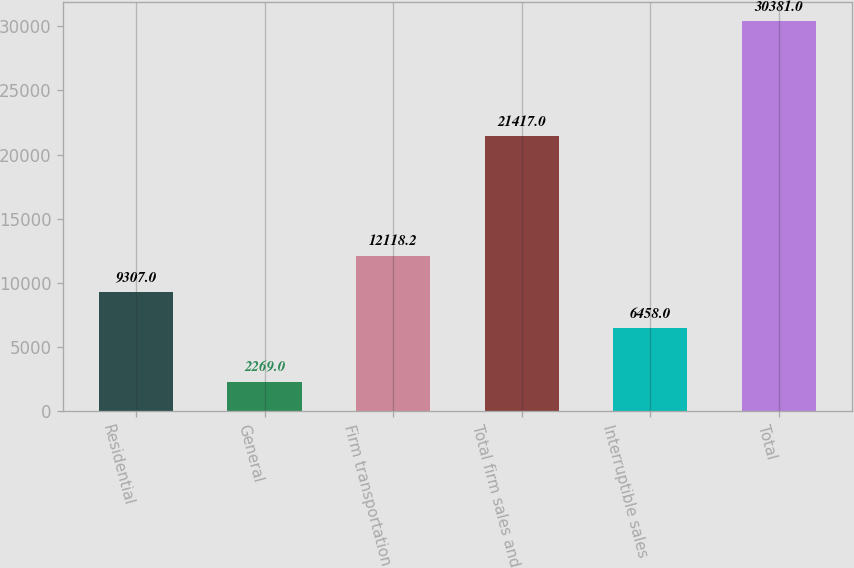Convert chart to OTSL. <chart><loc_0><loc_0><loc_500><loc_500><bar_chart><fcel>Residential<fcel>General<fcel>Firm transportation<fcel>Total firm sales and<fcel>Interruptible sales<fcel>Total<nl><fcel>9307<fcel>2269<fcel>12118.2<fcel>21417<fcel>6458<fcel>30381<nl></chart> 